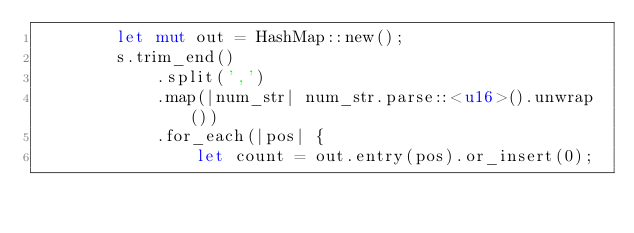Convert code to text. <code><loc_0><loc_0><loc_500><loc_500><_Rust_>        let mut out = HashMap::new();
        s.trim_end()
            .split(',')
            .map(|num_str| num_str.parse::<u16>().unwrap())
            .for_each(|pos| {
                let count = out.entry(pos).or_insert(0);</code> 